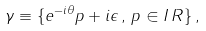Convert formula to latex. <formula><loc_0><loc_0><loc_500><loc_500>\gamma \equiv \{ e ^ { - i \theta } p + i \epsilon \, , \, p \in I \, R \} \, ,</formula> 